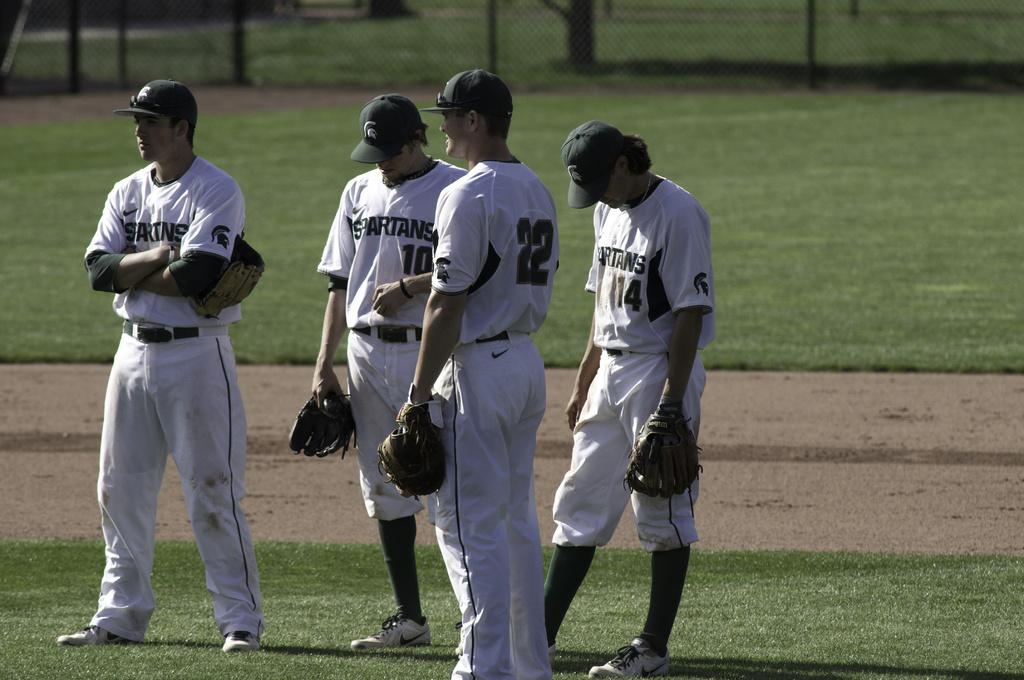Provide a one-sentence caption for the provided image. Player number 10 for the Spartans looks down at the field. 